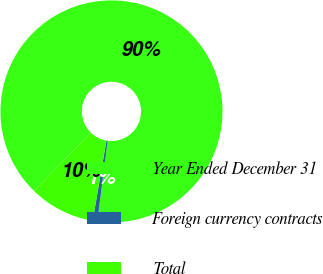<chart> <loc_0><loc_0><loc_500><loc_500><pie_chart><fcel>Year Ended December 31<fcel>Foreign currency contracts<fcel>Total<nl><fcel>89.75%<fcel>0.67%<fcel>9.58%<nl></chart> 